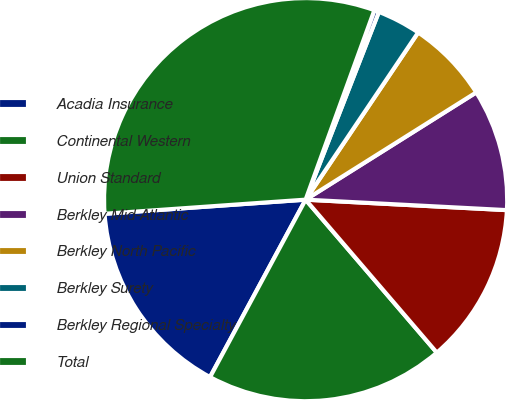Convert chart. <chart><loc_0><loc_0><loc_500><loc_500><pie_chart><fcel>Acadia Insurance<fcel>Continental Western<fcel>Union Standard<fcel>Berkley Mid-Atlantic<fcel>Berkley North Pacific<fcel>Berkley Surety<fcel>Berkley Regional Specialty<fcel>Total<nl><fcel>16.02%<fcel>19.15%<fcel>12.89%<fcel>9.76%<fcel>6.64%<fcel>3.51%<fcel>0.38%<fcel>31.66%<nl></chart> 